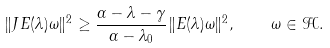Convert formula to latex. <formula><loc_0><loc_0><loc_500><loc_500>\| J E ( \lambda ) \omega \| ^ { 2 } \geq \frac { \alpha - \lambda - \gamma } { \alpha - \lambda _ { 0 } } \| E ( \lambda ) \omega \| ^ { 2 } , \quad \omega \in { \mathcal { H } } .</formula> 